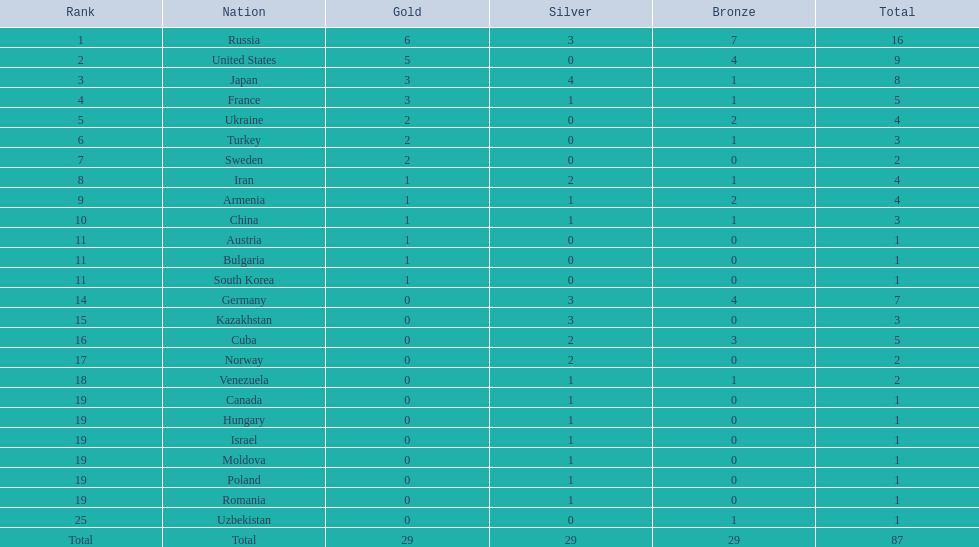In the 1995 worldwide wrestling championships, which countries took part? Russia, United States, Japan, France, Ukraine, Turkey, Sweden, Iran, Armenia, China, Austria, Bulgaria, South Korea, Germany, Kazakhstan, Cuba, Norway, Venezuela, Canada, Hungary, Israel, Moldova, Poland, Romania, Uzbekistan. What country achieved a single medal? Austria, Bulgaria, South Korea, Canada, Hungary, Israel, Moldova, Poland, Romania, Uzbekistan. Which one of these received a bronze medal? Uzbekistan. 